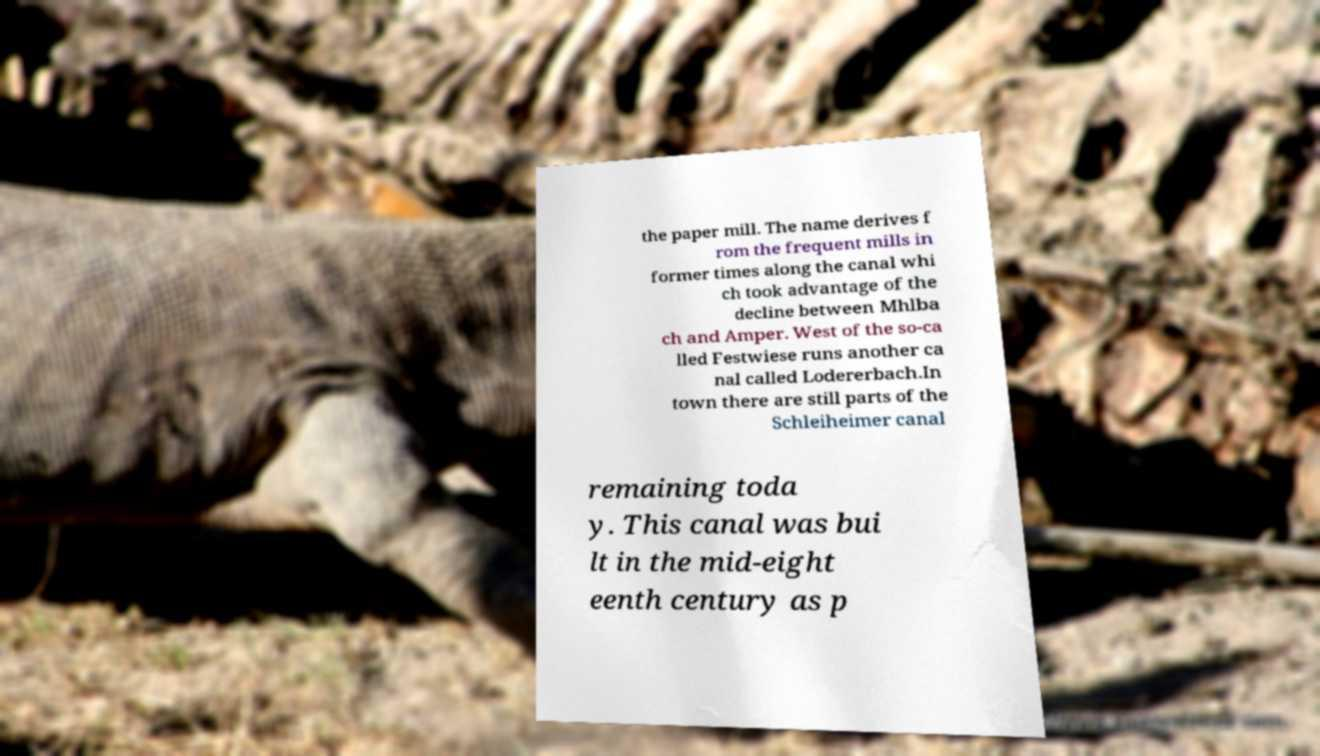Please identify and transcribe the text found in this image. the paper mill. The name derives f rom the frequent mills in former times along the canal whi ch took advantage of the decline between Mhlba ch and Amper. West of the so-ca lled Festwiese runs another ca nal called Lodererbach.In town there are still parts of the Schleiheimer canal remaining toda y. This canal was bui lt in the mid-eight eenth century as p 